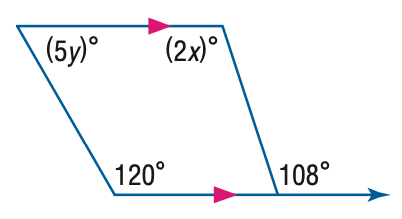Question: Find the value of the variable y in the figure.
Choices:
A. 12
B. 24
C. 60
D. 120
Answer with the letter. Answer: A 